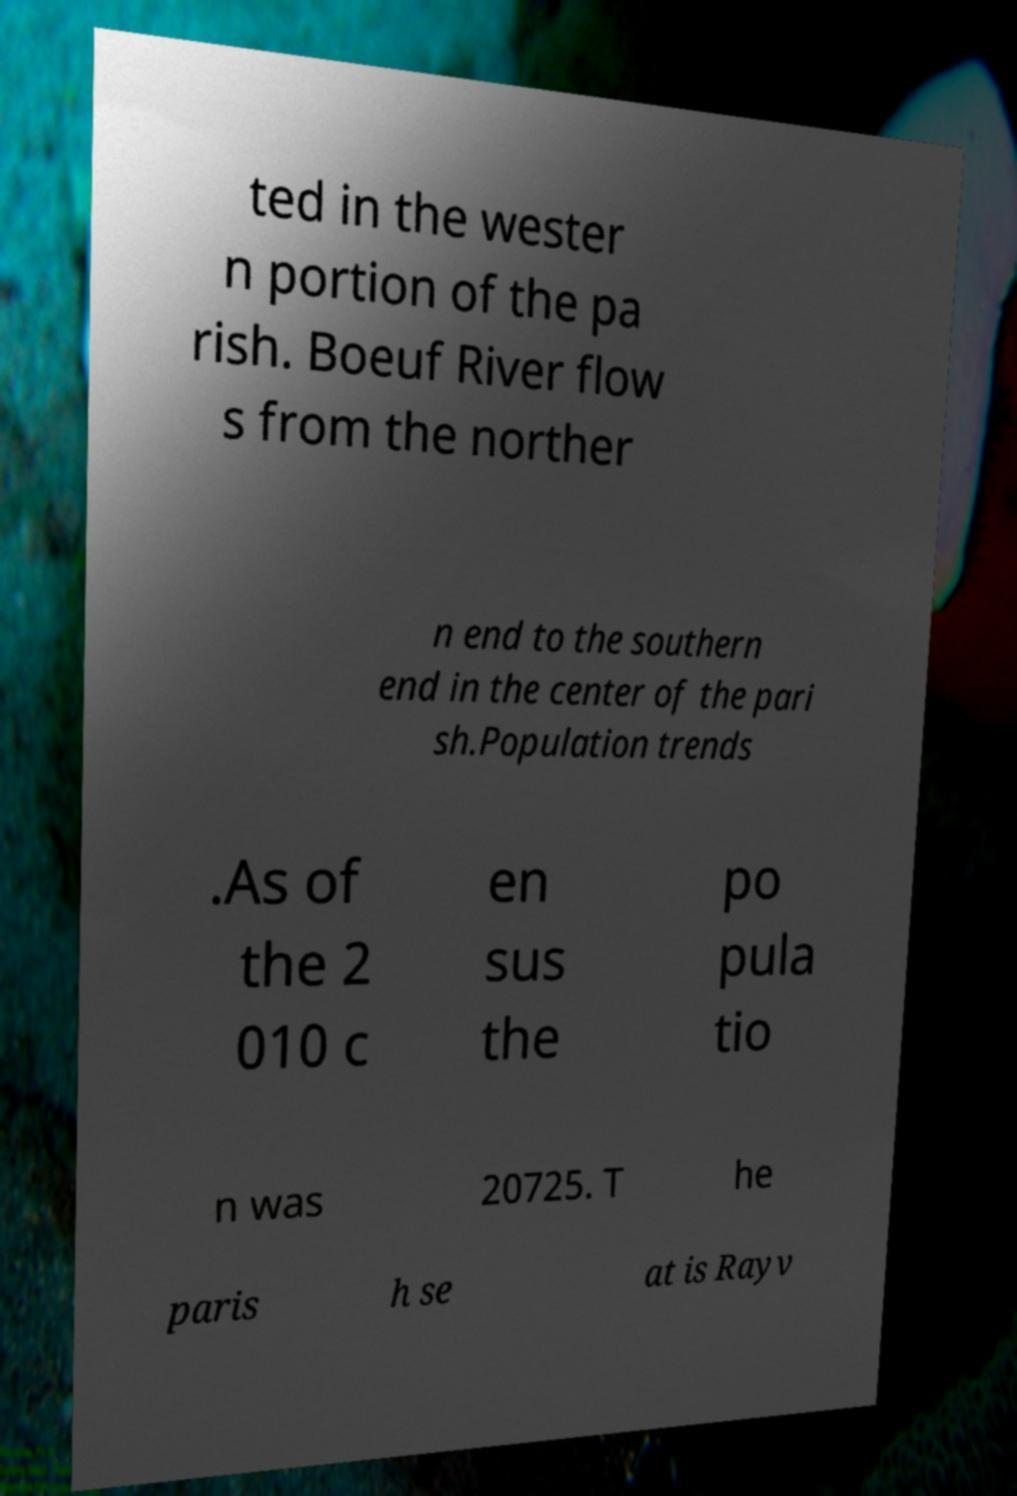Can you accurately transcribe the text from the provided image for me? ted in the wester n portion of the pa rish. Boeuf River flow s from the norther n end to the southern end in the center of the pari sh.Population trends .As of the 2 010 c en sus the po pula tio n was 20725. T he paris h se at is Rayv 